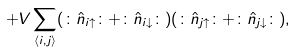<formula> <loc_0><loc_0><loc_500><loc_500>+ V \sum _ { \langle i , j \rangle } ( \colon \hat { n } _ { i \uparrow } \colon + \colon \hat { n } _ { i \downarrow } \colon ) ( \colon \hat { n } _ { j \uparrow } \colon + \colon \hat { n } _ { j \downarrow } \colon ) ,</formula> 